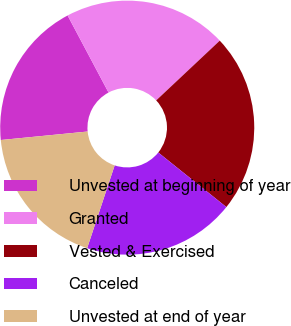Convert chart to OTSL. <chart><loc_0><loc_0><loc_500><loc_500><pie_chart><fcel>Unvested at beginning of year<fcel>Granted<fcel>Vested & Exercised<fcel>Canceled<fcel>Unvested at end of year<nl><fcel>18.78%<fcel>20.77%<fcel>22.76%<fcel>19.36%<fcel>18.34%<nl></chart> 